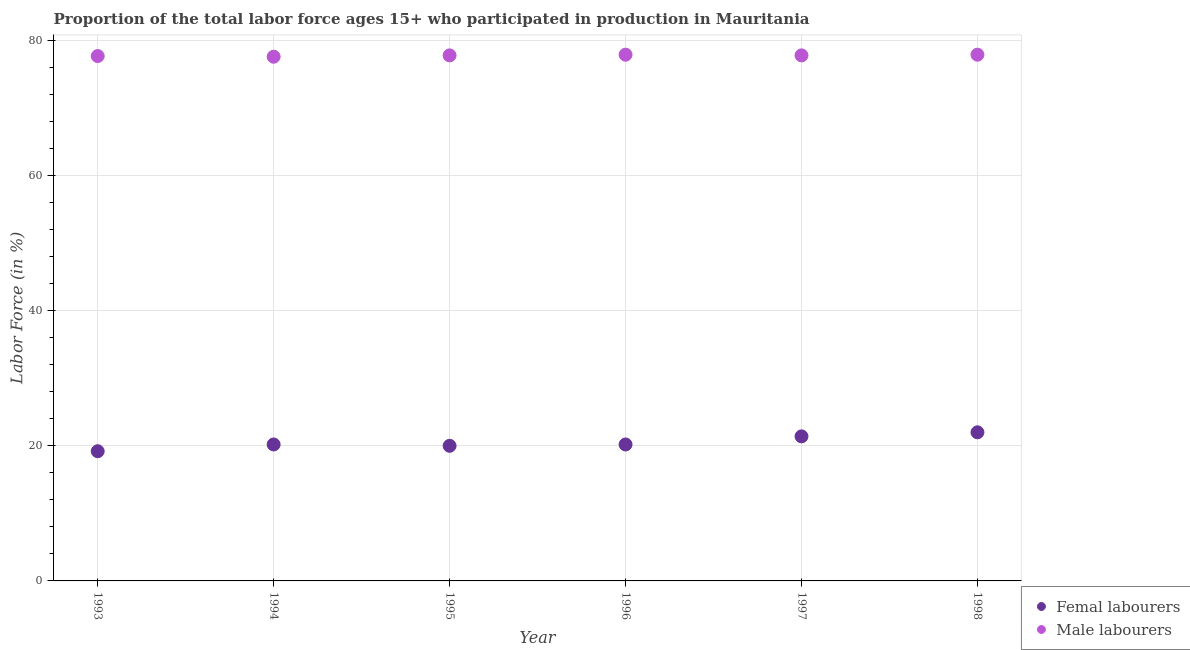How many different coloured dotlines are there?
Provide a succinct answer. 2. What is the percentage of male labour force in 1994?
Your answer should be compact. 77.6. Across all years, what is the maximum percentage of female labor force?
Make the answer very short. 22. Across all years, what is the minimum percentage of male labour force?
Ensure brevity in your answer.  77.6. In which year was the percentage of male labour force maximum?
Your answer should be compact. 1996. In which year was the percentage of female labor force minimum?
Ensure brevity in your answer.  1993. What is the total percentage of male labour force in the graph?
Make the answer very short. 466.7. What is the difference between the percentage of female labor force in 1995 and that in 1997?
Your answer should be compact. -1.4. What is the difference between the percentage of male labour force in 1998 and the percentage of female labor force in 1995?
Your answer should be very brief. 57.9. What is the average percentage of male labour force per year?
Give a very brief answer. 77.78. In the year 1994, what is the difference between the percentage of female labor force and percentage of male labour force?
Offer a terse response. -57.4. In how many years, is the percentage of male labour force greater than 64 %?
Provide a short and direct response. 6. What is the ratio of the percentage of male labour force in 1995 to that in 1996?
Keep it short and to the point. 1. Is the percentage of female labor force in 1993 less than that in 1994?
Your response must be concise. Yes. What is the difference between the highest and the second highest percentage of male labour force?
Your answer should be compact. 0. What is the difference between the highest and the lowest percentage of female labor force?
Offer a very short reply. 2.8. Does the percentage of male labour force monotonically increase over the years?
Provide a succinct answer. No. Are the values on the major ticks of Y-axis written in scientific E-notation?
Keep it short and to the point. No. Does the graph contain grids?
Your response must be concise. Yes. Where does the legend appear in the graph?
Keep it short and to the point. Bottom right. How many legend labels are there?
Ensure brevity in your answer.  2. How are the legend labels stacked?
Provide a short and direct response. Vertical. What is the title of the graph?
Your answer should be compact. Proportion of the total labor force ages 15+ who participated in production in Mauritania. Does "Chemicals" appear as one of the legend labels in the graph?
Make the answer very short. No. What is the label or title of the Y-axis?
Give a very brief answer. Labor Force (in %). What is the Labor Force (in %) of Femal labourers in 1993?
Your answer should be very brief. 19.2. What is the Labor Force (in %) in Male labourers in 1993?
Your answer should be very brief. 77.7. What is the Labor Force (in %) of Femal labourers in 1994?
Offer a very short reply. 20.2. What is the Labor Force (in %) of Male labourers in 1994?
Keep it short and to the point. 77.6. What is the Labor Force (in %) of Male labourers in 1995?
Keep it short and to the point. 77.8. What is the Labor Force (in %) of Femal labourers in 1996?
Give a very brief answer. 20.2. What is the Labor Force (in %) in Male labourers in 1996?
Your answer should be very brief. 77.9. What is the Labor Force (in %) of Femal labourers in 1997?
Your response must be concise. 21.4. What is the Labor Force (in %) in Male labourers in 1997?
Your response must be concise. 77.8. What is the Labor Force (in %) of Femal labourers in 1998?
Provide a succinct answer. 22. What is the Labor Force (in %) in Male labourers in 1998?
Keep it short and to the point. 77.9. Across all years, what is the maximum Labor Force (in %) in Femal labourers?
Provide a short and direct response. 22. Across all years, what is the maximum Labor Force (in %) in Male labourers?
Provide a succinct answer. 77.9. Across all years, what is the minimum Labor Force (in %) of Femal labourers?
Provide a succinct answer. 19.2. Across all years, what is the minimum Labor Force (in %) in Male labourers?
Your answer should be compact. 77.6. What is the total Labor Force (in %) of Femal labourers in the graph?
Your response must be concise. 123. What is the total Labor Force (in %) in Male labourers in the graph?
Provide a succinct answer. 466.7. What is the difference between the Labor Force (in %) in Femal labourers in 1993 and that in 1994?
Give a very brief answer. -1. What is the difference between the Labor Force (in %) of Male labourers in 1993 and that in 1994?
Provide a succinct answer. 0.1. What is the difference between the Labor Force (in %) in Femal labourers in 1993 and that in 1995?
Ensure brevity in your answer.  -0.8. What is the difference between the Labor Force (in %) of Male labourers in 1993 and that in 1995?
Offer a terse response. -0.1. What is the difference between the Labor Force (in %) in Male labourers in 1993 and that in 1996?
Keep it short and to the point. -0.2. What is the difference between the Labor Force (in %) of Femal labourers in 1993 and that in 1997?
Offer a very short reply. -2.2. What is the difference between the Labor Force (in %) in Male labourers in 1994 and that in 1995?
Offer a terse response. -0.2. What is the difference between the Labor Force (in %) of Femal labourers in 1994 and that in 1996?
Provide a succinct answer. 0. What is the difference between the Labor Force (in %) of Femal labourers in 1994 and that in 1997?
Keep it short and to the point. -1.2. What is the difference between the Labor Force (in %) in Male labourers in 1994 and that in 1997?
Provide a short and direct response. -0.2. What is the difference between the Labor Force (in %) in Male labourers in 1994 and that in 1998?
Offer a very short reply. -0.3. What is the difference between the Labor Force (in %) of Male labourers in 1995 and that in 1998?
Your answer should be compact. -0.1. What is the difference between the Labor Force (in %) of Femal labourers in 1996 and that in 1997?
Provide a short and direct response. -1.2. What is the difference between the Labor Force (in %) of Femal labourers in 1996 and that in 1998?
Offer a terse response. -1.8. What is the difference between the Labor Force (in %) of Male labourers in 1997 and that in 1998?
Your answer should be very brief. -0.1. What is the difference between the Labor Force (in %) in Femal labourers in 1993 and the Labor Force (in %) in Male labourers in 1994?
Your answer should be compact. -58.4. What is the difference between the Labor Force (in %) of Femal labourers in 1993 and the Labor Force (in %) of Male labourers in 1995?
Provide a short and direct response. -58.6. What is the difference between the Labor Force (in %) in Femal labourers in 1993 and the Labor Force (in %) in Male labourers in 1996?
Ensure brevity in your answer.  -58.7. What is the difference between the Labor Force (in %) in Femal labourers in 1993 and the Labor Force (in %) in Male labourers in 1997?
Your response must be concise. -58.6. What is the difference between the Labor Force (in %) in Femal labourers in 1993 and the Labor Force (in %) in Male labourers in 1998?
Make the answer very short. -58.7. What is the difference between the Labor Force (in %) in Femal labourers in 1994 and the Labor Force (in %) in Male labourers in 1995?
Provide a short and direct response. -57.6. What is the difference between the Labor Force (in %) of Femal labourers in 1994 and the Labor Force (in %) of Male labourers in 1996?
Make the answer very short. -57.7. What is the difference between the Labor Force (in %) of Femal labourers in 1994 and the Labor Force (in %) of Male labourers in 1997?
Provide a succinct answer. -57.6. What is the difference between the Labor Force (in %) in Femal labourers in 1994 and the Labor Force (in %) in Male labourers in 1998?
Provide a succinct answer. -57.7. What is the difference between the Labor Force (in %) of Femal labourers in 1995 and the Labor Force (in %) of Male labourers in 1996?
Ensure brevity in your answer.  -57.9. What is the difference between the Labor Force (in %) of Femal labourers in 1995 and the Labor Force (in %) of Male labourers in 1997?
Your response must be concise. -57.8. What is the difference between the Labor Force (in %) of Femal labourers in 1995 and the Labor Force (in %) of Male labourers in 1998?
Ensure brevity in your answer.  -57.9. What is the difference between the Labor Force (in %) in Femal labourers in 1996 and the Labor Force (in %) in Male labourers in 1997?
Keep it short and to the point. -57.6. What is the difference between the Labor Force (in %) of Femal labourers in 1996 and the Labor Force (in %) of Male labourers in 1998?
Keep it short and to the point. -57.7. What is the difference between the Labor Force (in %) in Femal labourers in 1997 and the Labor Force (in %) in Male labourers in 1998?
Give a very brief answer. -56.5. What is the average Labor Force (in %) in Femal labourers per year?
Provide a succinct answer. 20.5. What is the average Labor Force (in %) of Male labourers per year?
Offer a terse response. 77.78. In the year 1993, what is the difference between the Labor Force (in %) of Femal labourers and Labor Force (in %) of Male labourers?
Your answer should be compact. -58.5. In the year 1994, what is the difference between the Labor Force (in %) of Femal labourers and Labor Force (in %) of Male labourers?
Offer a very short reply. -57.4. In the year 1995, what is the difference between the Labor Force (in %) in Femal labourers and Labor Force (in %) in Male labourers?
Ensure brevity in your answer.  -57.8. In the year 1996, what is the difference between the Labor Force (in %) in Femal labourers and Labor Force (in %) in Male labourers?
Your response must be concise. -57.7. In the year 1997, what is the difference between the Labor Force (in %) of Femal labourers and Labor Force (in %) of Male labourers?
Your answer should be compact. -56.4. In the year 1998, what is the difference between the Labor Force (in %) of Femal labourers and Labor Force (in %) of Male labourers?
Keep it short and to the point. -55.9. What is the ratio of the Labor Force (in %) in Femal labourers in 1993 to that in 1994?
Your answer should be very brief. 0.95. What is the ratio of the Labor Force (in %) in Male labourers in 1993 to that in 1995?
Provide a succinct answer. 1. What is the ratio of the Labor Force (in %) of Femal labourers in 1993 to that in 1996?
Ensure brevity in your answer.  0.95. What is the ratio of the Labor Force (in %) in Male labourers in 1993 to that in 1996?
Offer a terse response. 1. What is the ratio of the Labor Force (in %) of Femal labourers in 1993 to that in 1997?
Your response must be concise. 0.9. What is the ratio of the Labor Force (in %) in Femal labourers in 1993 to that in 1998?
Offer a very short reply. 0.87. What is the ratio of the Labor Force (in %) of Femal labourers in 1994 to that in 1995?
Make the answer very short. 1.01. What is the ratio of the Labor Force (in %) in Male labourers in 1994 to that in 1995?
Give a very brief answer. 1. What is the ratio of the Labor Force (in %) of Femal labourers in 1994 to that in 1996?
Offer a terse response. 1. What is the ratio of the Labor Force (in %) in Male labourers in 1994 to that in 1996?
Your answer should be very brief. 1. What is the ratio of the Labor Force (in %) in Femal labourers in 1994 to that in 1997?
Ensure brevity in your answer.  0.94. What is the ratio of the Labor Force (in %) of Male labourers in 1994 to that in 1997?
Give a very brief answer. 1. What is the ratio of the Labor Force (in %) in Femal labourers in 1994 to that in 1998?
Provide a short and direct response. 0.92. What is the ratio of the Labor Force (in %) in Male labourers in 1994 to that in 1998?
Your response must be concise. 1. What is the ratio of the Labor Force (in %) in Male labourers in 1995 to that in 1996?
Make the answer very short. 1. What is the ratio of the Labor Force (in %) of Femal labourers in 1995 to that in 1997?
Your answer should be compact. 0.93. What is the ratio of the Labor Force (in %) in Male labourers in 1995 to that in 1997?
Ensure brevity in your answer.  1. What is the ratio of the Labor Force (in %) in Femal labourers in 1996 to that in 1997?
Offer a very short reply. 0.94. What is the ratio of the Labor Force (in %) of Male labourers in 1996 to that in 1997?
Provide a short and direct response. 1. What is the ratio of the Labor Force (in %) of Femal labourers in 1996 to that in 1998?
Provide a short and direct response. 0.92. What is the ratio of the Labor Force (in %) in Male labourers in 1996 to that in 1998?
Your response must be concise. 1. What is the ratio of the Labor Force (in %) of Femal labourers in 1997 to that in 1998?
Keep it short and to the point. 0.97. What is the ratio of the Labor Force (in %) in Male labourers in 1997 to that in 1998?
Provide a succinct answer. 1. What is the difference between the highest and the lowest Labor Force (in %) of Male labourers?
Offer a very short reply. 0.3. 